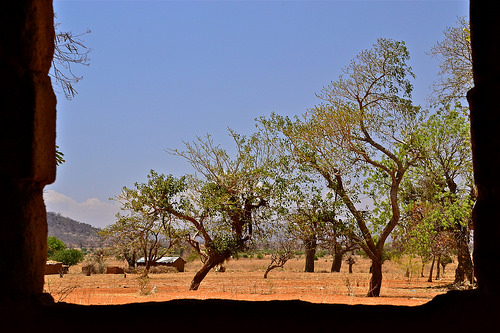<image>
Can you confirm if the tree is under the sky? Yes. The tree is positioned underneath the sky, with the sky above it in the vertical space. 